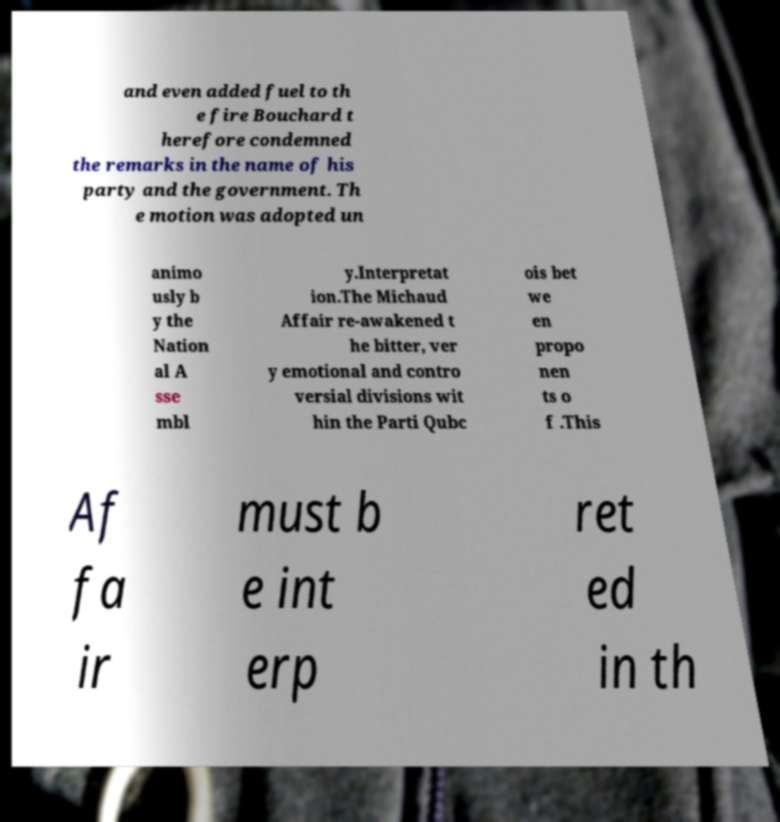What messages or text are displayed in this image? I need them in a readable, typed format. and even added fuel to th e fire Bouchard t herefore condemned the remarks in the name of his party and the government. Th e motion was adopted un animo usly b y the Nation al A sse mbl y.Interpretat ion.The Michaud Affair re-awakened t he bitter, ver y emotional and contro versial divisions wit hin the Parti Qubc ois bet we en propo nen ts o f .This Af fa ir must b e int erp ret ed in th 